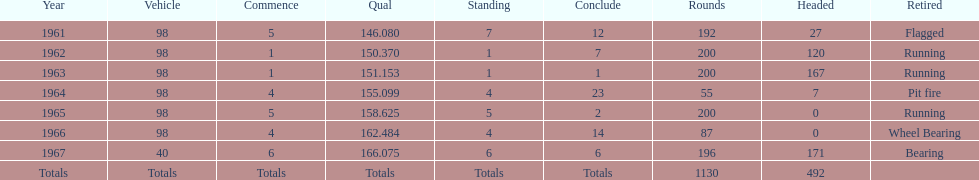What was his best finish before his first win? 7. 